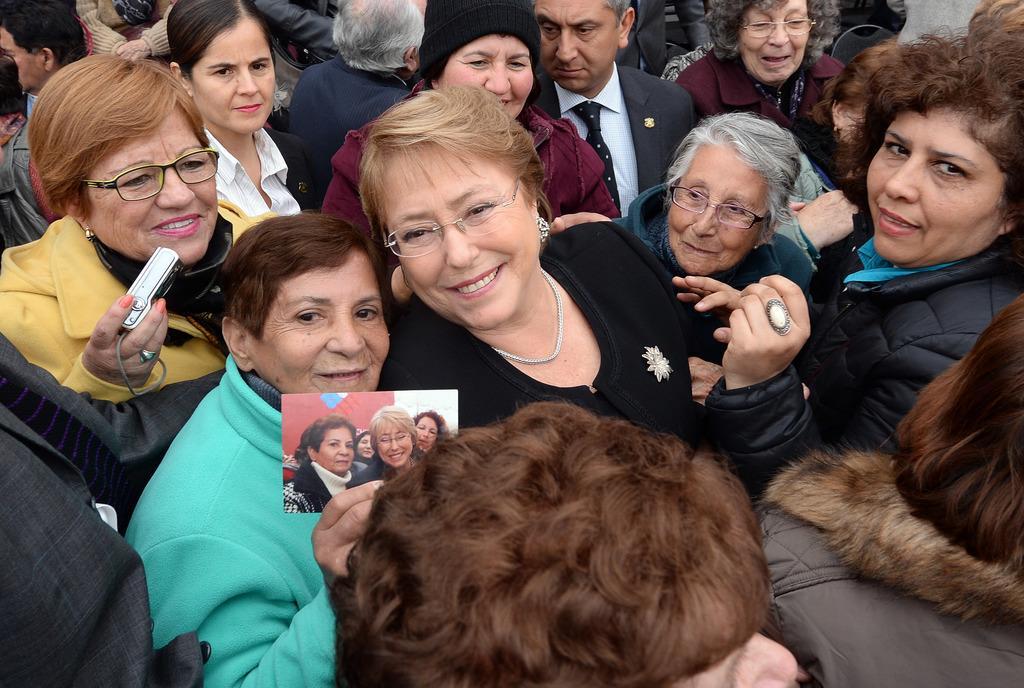Could you give a brief overview of what you see in this image? This image is taken outdoors. In this image there are many people with smiling faces. 